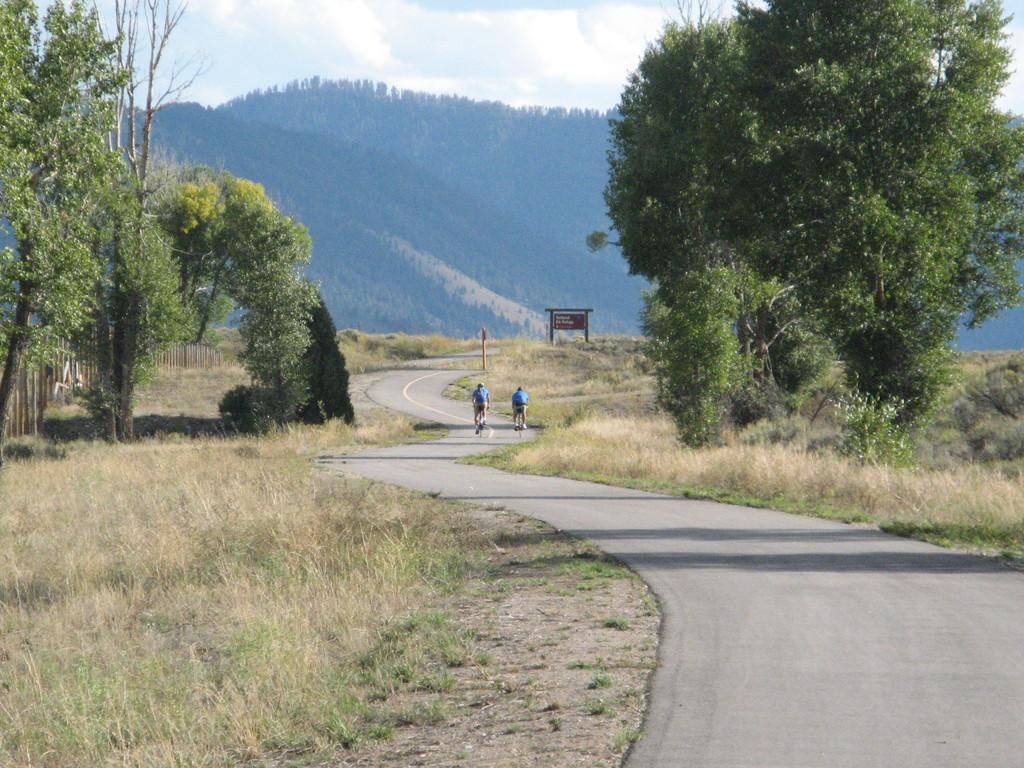How would you summarize this image in a sentence or two? In the middle of the image we can see few people, they are riding bicycles on the road, in the background we can see few trees, grass, hills and a board. 